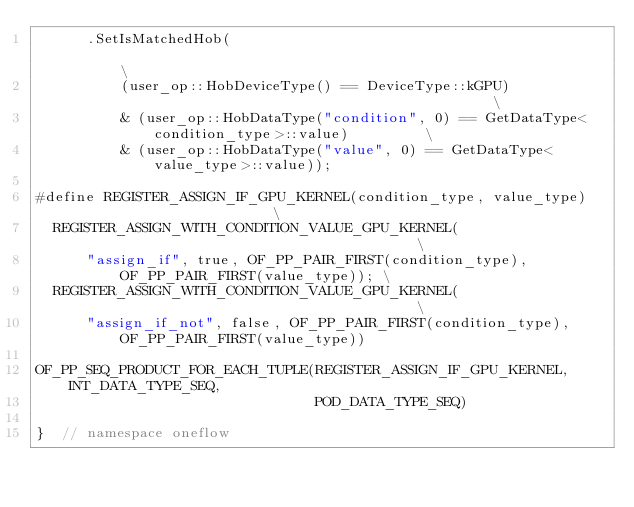Convert code to text. <code><loc_0><loc_0><loc_500><loc_500><_Cuda_>      .SetIsMatchedHob(                                                                          \
          (user_op::HobDeviceType() == DeviceType::kGPU)                                         \
          & (user_op::HobDataType("condition", 0) == GetDataType<condition_type>::value)         \
          & (user_op::HobDataType("value", 0) == GetDataType<value_type>::value));

#define REGISTER_ASSIGN_IF_GPU_KERNEL(condition_type, value_type)                         \
  REGISTER_ASSIGN_WITH_CONDITION_VALUE_GPU_KERNEL(                                        \
      "assign_if", true, OF_PP_PAIR_FIRST(condition_type), OF_PP_PAIR_FIRST(value_type)); \
  REGISTER_ASSIGN_WITH_CONDITION_VALUE_GPU_KERNEL(                                        \
      "assign_if_not", false, OF_PP_PAIR_FIRST(condition_type), OF_PP_PAIR_FIRST(value_type))

OF_PP_SEQ_PRODUCT_FOR_EACH_TUPLE(REGISTER_ASSIGN_IF_GPU_KERNEL, INT_DATA_TYPE_SEQ,
                                 POD_DATA_TYPE_SEQ)

}  // namespace oneflow
</code> 